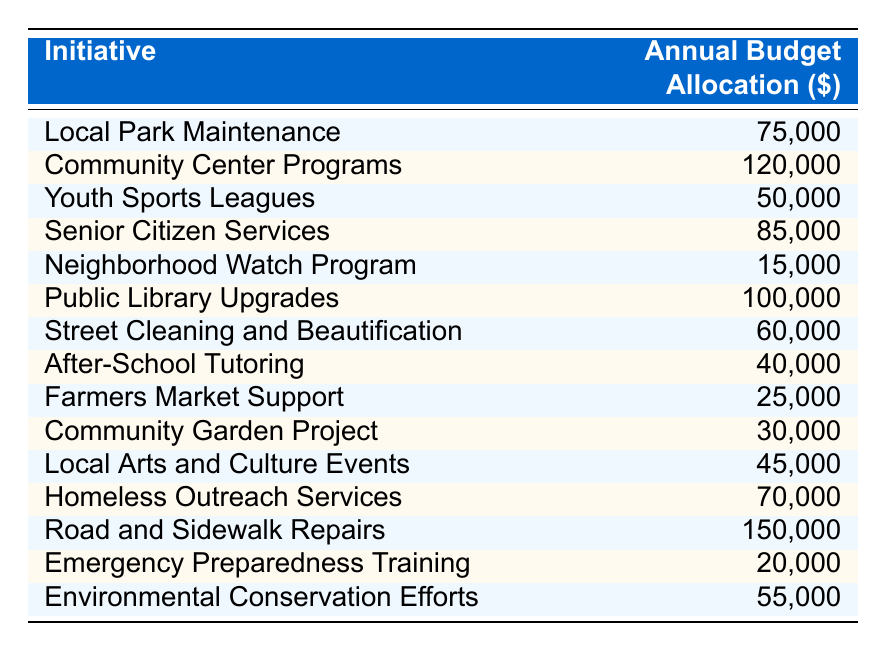What is the budget allocation for the Community Center Programs? The table lists the budget allocation for each initiative. The value for Community Center Programs is directly shown as 120,000.
Answer: 120,000 Which initiative has the highest budget allocation? By examining the budget allocations, we can see that the Road and Sidewalk Repairs have the highest amount, which is 150,000.
Answer: Road and Sidewalk Repairs What is the total budget allocation for Senior Citizen Services and Homeless Outreach Services? The allocation for Senior Citizen Services is 85,000 and for Homeless Outreach Services is 70,000. Adding these together: 85,000 + 70,000 = 155,000.
Answer: 155,000 Is the budget for Youth Sports Leagues more than that for Environmental Conservation Efforts? The budget for Youth Sports Leagues is 50,000 while Environmental Conservation Efforts is 55,000. Since 50,000 is less than 55,000, the statement is false.
Answer: No What is the average budget allocation for the Neighborhood Watch Program, Emergency Preparedness Training, and Farmers Market Support? The budget allocations are 15,000 for the Neighborhood Watch Program, 20,000 for Emergency Preparedness Training, and 25,000 for Farmers Market Support. First, sum them: 15,000 + 20,000 + 25,000 = 60,000. Then divide by 3 for the average: 60,000 / 3 = 20,000.
Answer: 20,000 How much more is allocated to the Public Library Upgrades compared to the Community Garden Project? The budget for Public Library Upgrades is 100,000, while the Community Garden Project has 30,000. To find the difference: 100,000 - 30,000 = 70,000.
Answer: 70,000 Which initiative has a budget allocation of 40,000? After reviewing the initiatives, After-School Tutoring is the only one with an allocation directly stated as 40,000.
Answer: After-School Tutoring If the total budget allocation for environmental initiatives (including Environmental Conservation Efforts and the Community Garden Project) is calculated, what would it be? The allocation for Environmental Conservation Efforts is 55,000 and for the Community Garden Project, it is 30,000. Their sum is 55,000 + 30,000 = 85,000.
Answer: 85,000 Are there more initiatives with a budget allocation of 50,000 or less compared to those with 100,000 or more? Initiatives with 50,000 or less include: Youth Sports Leagues (50,000), Neighborhood Watch Program (15,000), After-School Tutoring (40,000), Farmers Market Support (25,000), and Community Garden Project (30,000) — totaling 5. Initiatives with 100,000 or more are Public Library Upgrades (100,000) and Road and Sidewalk Repairs (150,000) — totaling 2. Thus, there are more initiatives with budgets of 50,000 or less.
Answer: Yes What percentage of the total budget allocation does the Local Park Maintenance represent? First, sum all budget allocations: 75,000 + 120,000 + 50,000 + 85,000 + 15,000 + 100,000 + 60,000 + 40,000 + 25,000 + 30,000 + 45,000 + 70,000 + 150,000 + 20,000 + 55,000 = 1,025,000. Local Park Maintenance's budget is 75,000. To calculate the percentage: (75,000 / 1,025,000) * 100 = 7.32%.
Answer: 7.32% 